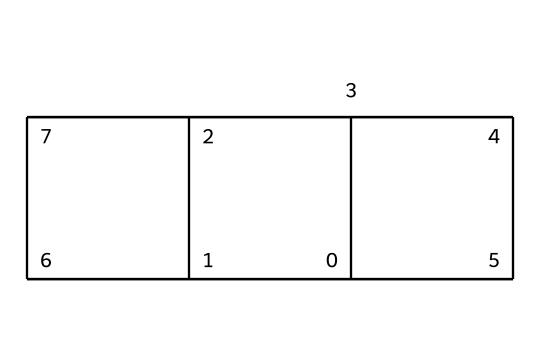What is the molecular formula of cubane? By analyzing the structure derived from the SMILES, we can count the number of carbon (C) and hydrogen (H) atoms. Cubane has 8 carbon atoms and 8 hydrogen atoms, giving the molecular formula C8H8.
Answer: C8H8 How many carbon atoms are present in cubane? From the SMILES representation, we can identify that there are a total of 8 carbon atoms in the structure.
Answer: 8 What is the hybridization of the carbon atoms in cubane? In cubane, all the carbon atoms are sp3 hybridized due to the tetrahedral geometry of the bonds formed. Each carbon is bonded to other carbons in such a way that they form a three-dimensional cubic structure.
Answer: sp3 How does cubane's structure compare to other hydrocarbons? Cubane is unique as it has a three-dimensional cubic structure, unlike most hydrocarbons which tend to form linear or branched structures. This distinct cubic arrangement distinguishes it from other simple hydrocarbons such as alkanes.
Answer: cubic Is cubane a saturated or unsaturated hydrocarbon? Cubane contains only single bonds between carbon atoms, which classifies it as a saturated hydrocarbon. There are no double or triple bonds present in its structure.
Answer: saturated What type of cage compound is cubane specifically classified as? Cubane is classified as a polyhedral or cage hydrocarbon due to its three-dimensional, closed structure formed by the carbon atoms. This is characteristic of cage compounds.
Answer: polyhedral 